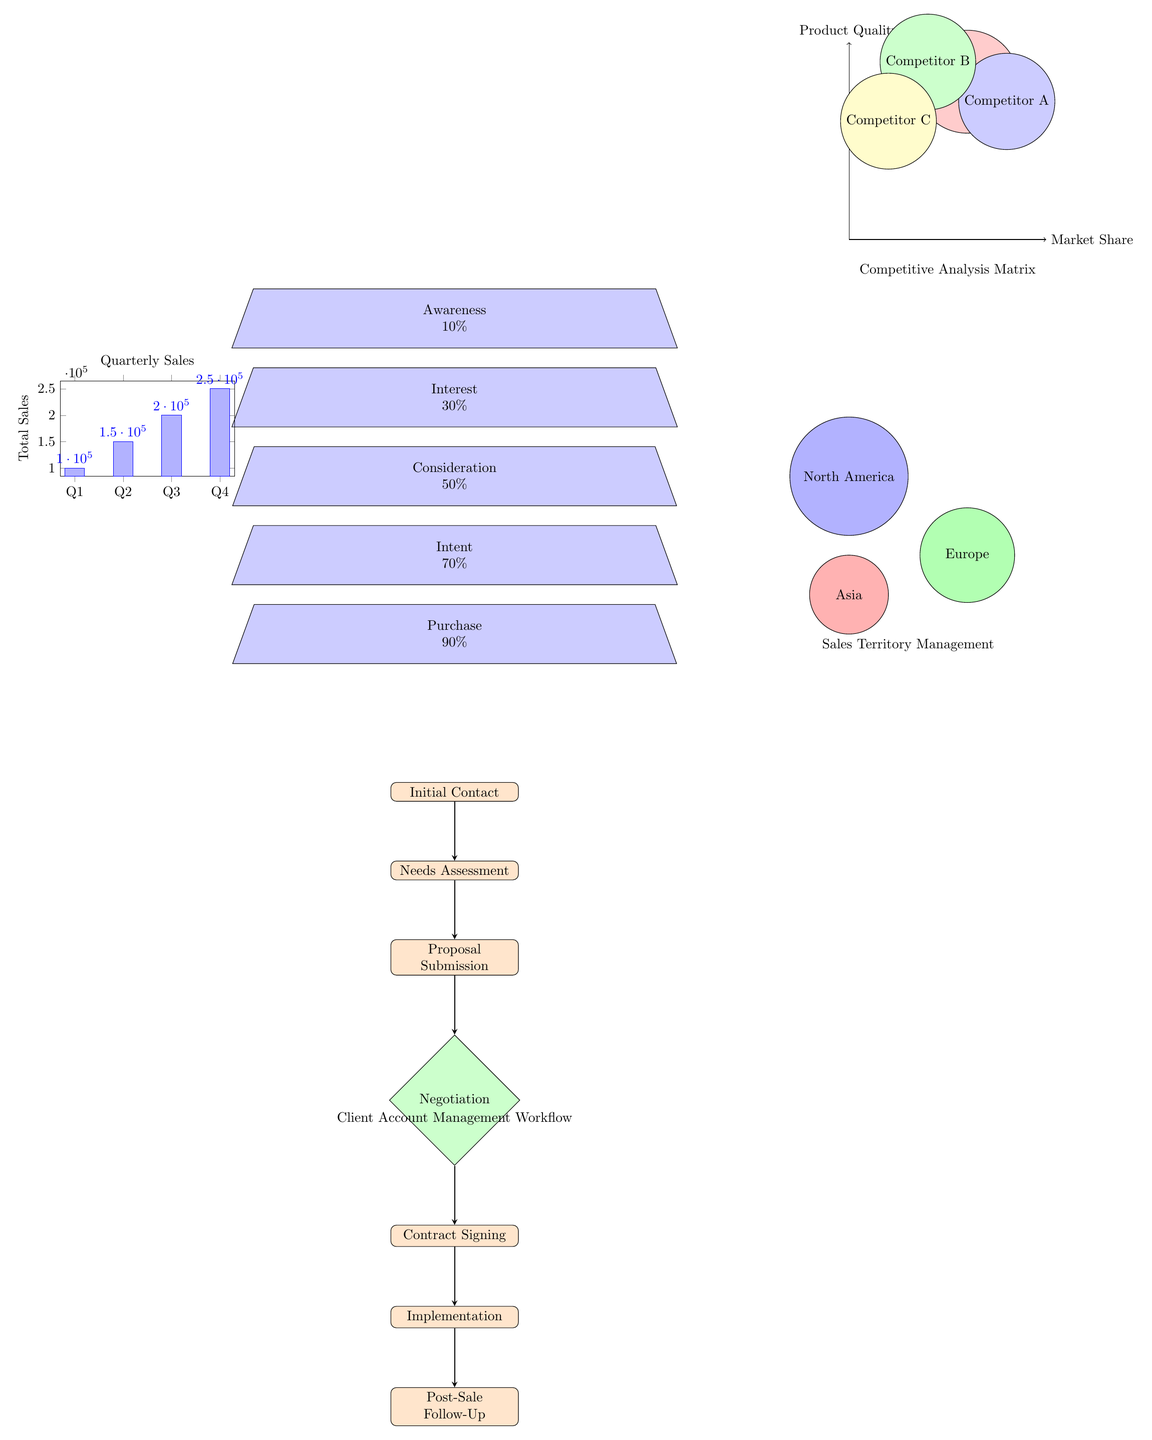What is the conversion rate at the Awareness stage? The diagram shows that the Awareness stage has a conversion rate marked as 10%. Therefore, the answer can be directly taken from this specific node.
Answer: 10% What is the name of the sales territory colored green? In the diagram, the green territory identifies Europe, as indicated in the geographic representation.
Answer: Europe How many stages are in the Client Acquisition Funnel? The diagram lists five stages: Awareness, Interest, Consideration, Intent, and Purchase. Counting these stages gives the total stages.
Answer: 5 Which stage follows Needs Assessment in the Client Account Management Workflow? Following the Needs Assessment step, the diagram indicates that the next step is Proposal Submission, based on the flow of tasks shown.
Answer: Proposal Submission What is the market share position of Your Company in the Competitive Analysis Matrix? In the Competitive Analysis Matrix, Your Company is represented in the third quadrant according to its market share and product quality. This position can be directly identified from the matrix.
Answer: 3, 4 What is the total sales for Quarter 4? The Quarterly Sales Performance Dashboard indicates that Total Sales for Quarter 4 is marked as 250000, which is also near the top of the bar representing Q4.
Answer: 250000 What is the final step in the Client Account Management Workflow? The diagram indicates that the final step in the workflow is Post-Sale Follow-Up, located at the bottom of the flowchart representation.
Answer: Post-Sale Follow-Up What is the color indicating Asia in the Sales Territory Management? The diagram uses red to signify the Asian sales territory, and this is clearly labeled in the diagram.
Answer: Red What comes before the Contract Signing in the Client Account Management Workflow? The diagram illustrates that the step before Contract Signing is Negotiation, based on the sequential flow of processes depicted.
Answer: Negotiation 